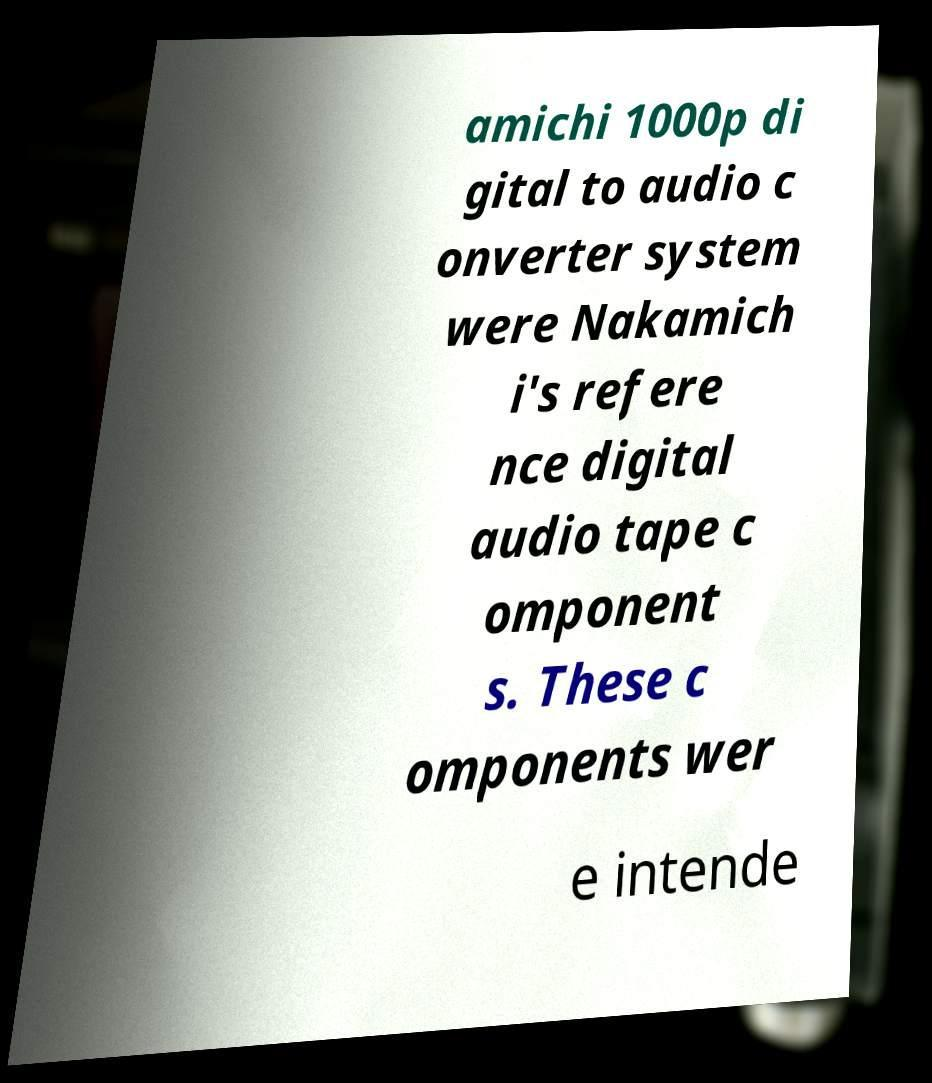Could you extract and type out the text from this image? amichi 1000p di gital to audio c onverter system were Nakamich i's refere nce digital audio tape c omponent s. These c omponents wer e intende 